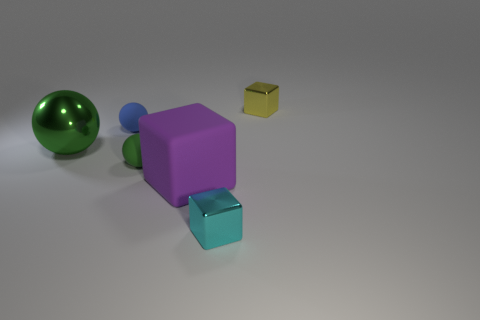What number of other things are the same color as the matte block?
Offer a terse response. 0. What material is the tiny cube to the left of the small block that is behind the big object on the left side of the large matte object?
Offer a very short reply. Metal. How many cylinders are green shiny things or cyan metal things?
Keep it short and to the point. 0. Is there anything else that has the same size as the purple object?
Offer a terse response. Yes. How many small green things are in front of the metallic cube that is left of the object to the right of the cyan metallic block?
Make the answer very short. 0. Does the yellow thing have the same shape as the purple matte thing?
Give a very brief answer. Yes. Is the material of the small block that is in front of the yellow shiny object the same as the small cube on the right side of the tiny cyan thing?
Provide a short and direct response. Yes. What number of things are either metal things behind the tiny green matte sphere or small shiny blocks on the left side of the small yellow cube?
Ensure brevity in your answer.  3. Is there anything else that has the same shape as the tiny yellow metal object?
Your response must be concise. Yes. How many large red cylinders are there?
Provide a short and direct response. 0. 